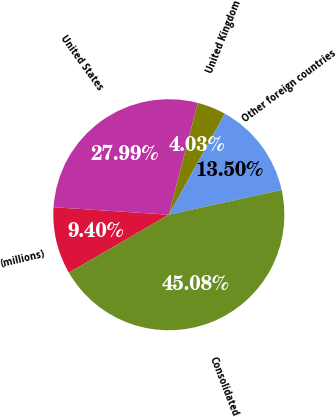Convert chart to OTSL. <chart><loc_0><loc_0><loc_500><loc_500><pie_chart><fcel>(millions)<fcel>United States<fcel>United Kingdom<fcel>Other foreign countries<fcel>Consolidated<nl><fcel>9.4%<fcel>27.99%<fcel>4.03%<fcel>13.5%<fcel>45.08%<nl></chart> 